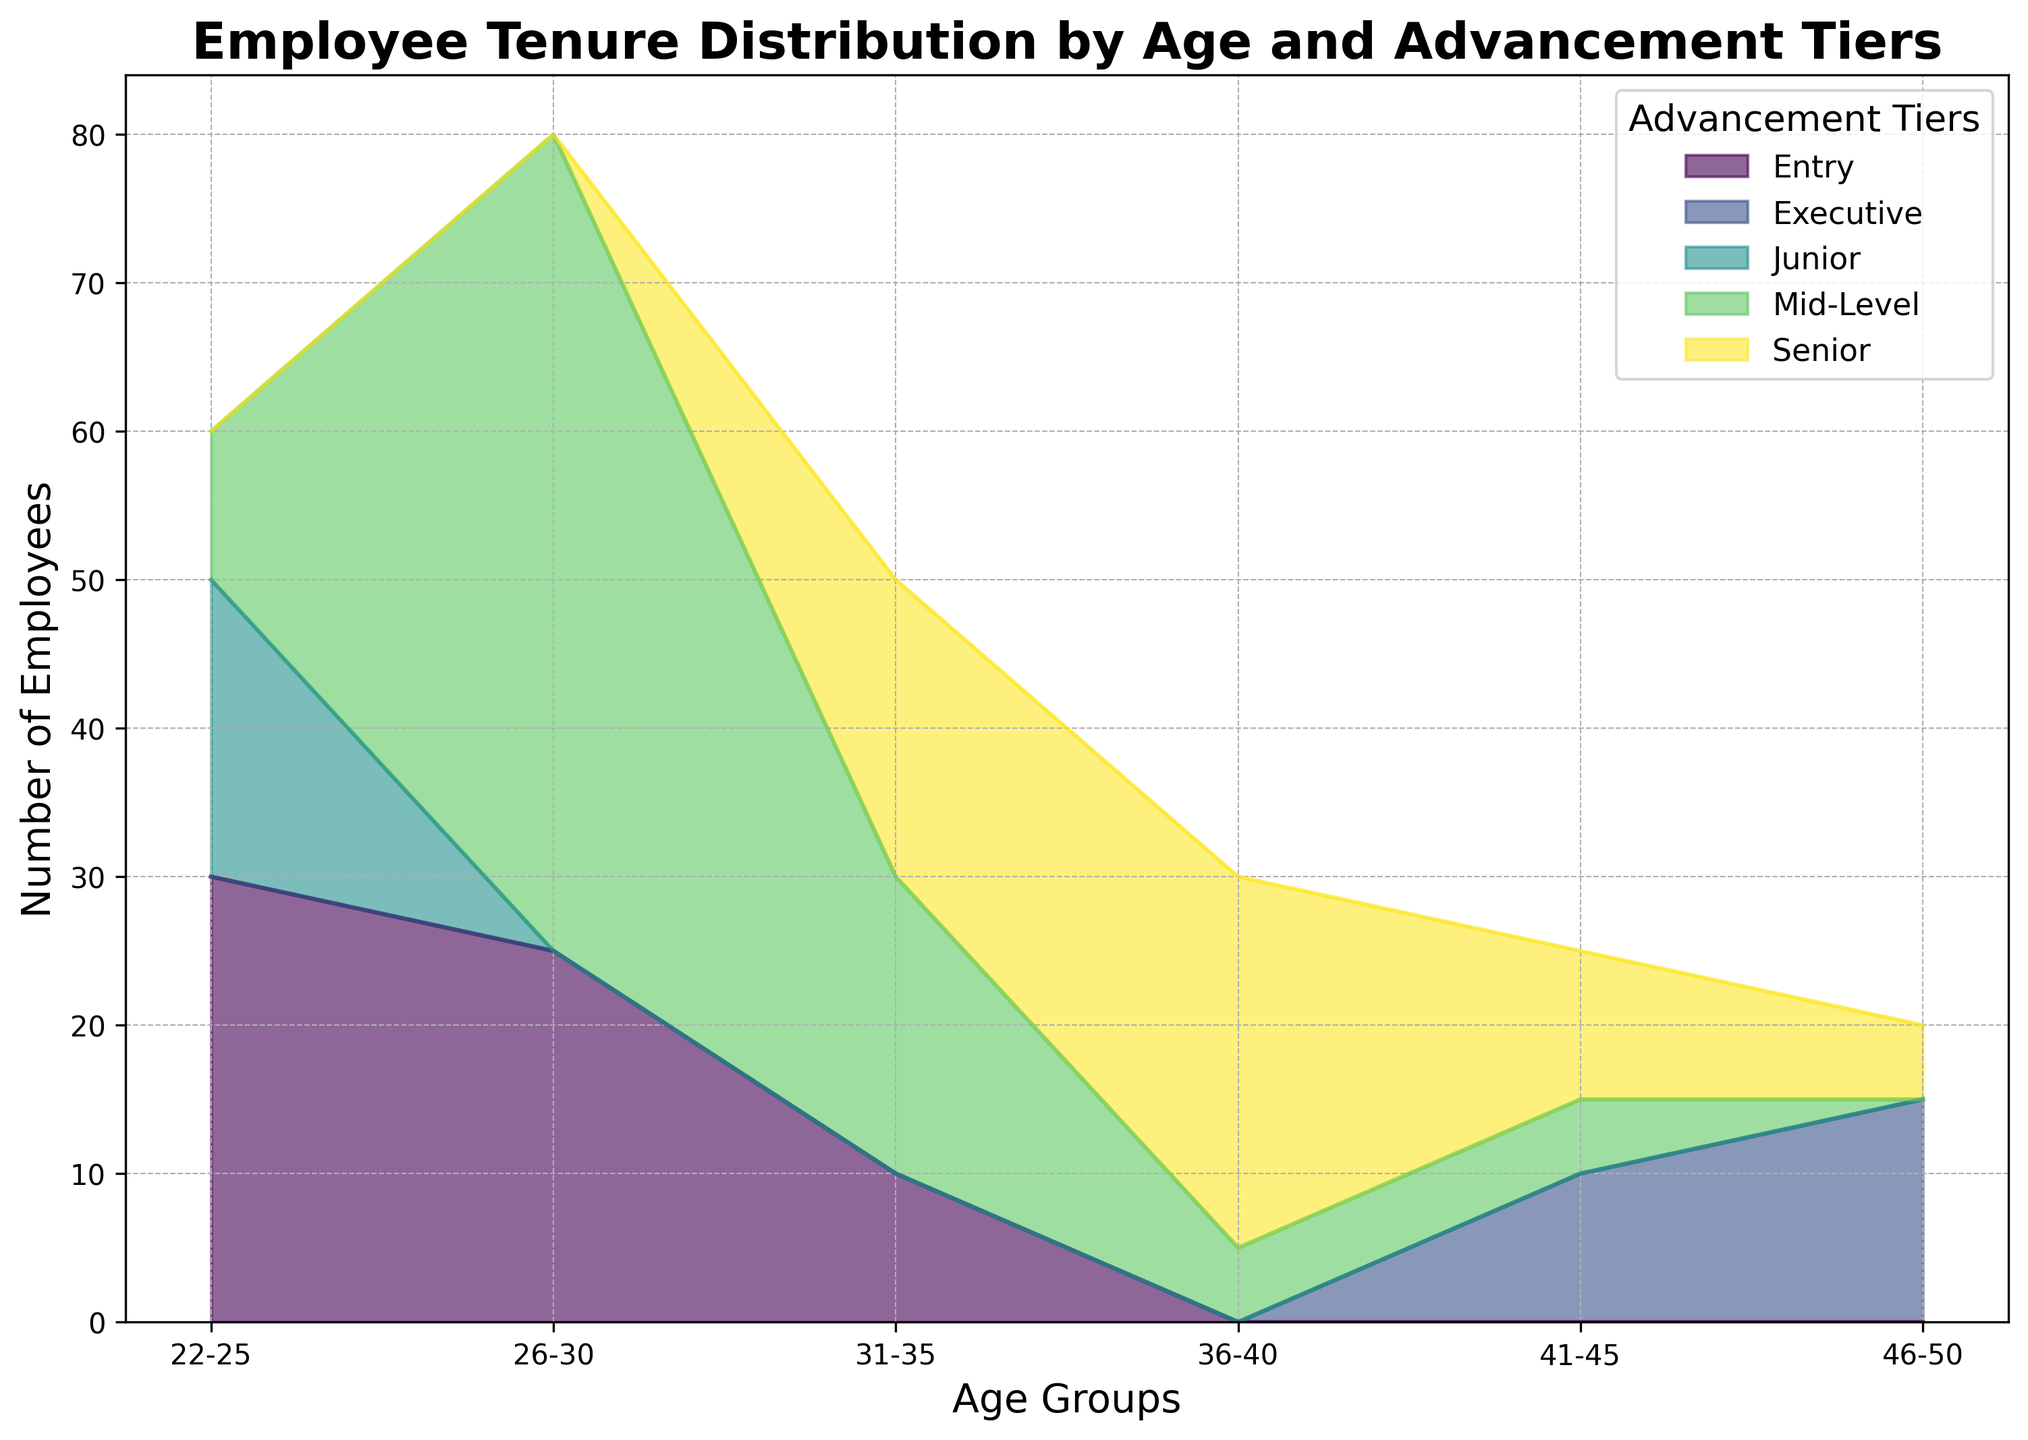What is the total number of employees in the 22-25 age group? To find the total number of employees in the 22-25 age group, sum the employee counts across all advancement tiers within that age group: 30 (Entry) + 20 (Junior) + 10 (Mid-Level) = 60
Answer: 60 Which advancement tier has the highest number of employees in the 31-35 age group? Look at the height of the area plots for the 31-35 age group. The tier with the largest visual area is Mid-Level, showing the highest employee count of 20.
Answer: Mid-Level How many employees in the 36-40 age group are in the Senior tier? Observe the visual segment corresponding to the Senior tier for the 36-40 age group. The count indicated is 15 employees.
Answer: 15 Which age group has the highest number of Entry level employees? Compare the visual height of the Entry tier areas across all age groups. The 22-25 age group has the highest visual area for Entry level with a count of 30 employees.
Answer: 22-25 Compare the total employees in the Senior tier across all age groups to the total employees in the Executive tier across all age groups. Which tier has more employees? Sum the employees for each age group in both the Senior and Executive tiers. Senior: 20 (31-35) + 10 (36-40) + 10 (41-45) + 5 (46-50) = 45. Executive: 10 (41-45) + 10 (46-50) + 5 (46-50) = 25. Therefore, the Senior tier has more employees.
Answer: Senior In the 26-30 age group, how many more employees are in the Mid-Level tier compared to the Entry tier? Identify the employee counts for the 26-30 age group: Mid-Level is 30+25=55, and Entry is 25. The difference is 55 - 25 = 30
Answer: 30 What's the total number of employees with 5-10 years of tenure across all age groups? Sum the counts for 5-10 years of tenure across all relevant age groups: 25 (26-30, Mid) + 20 (31-35, Mid) + 5 (36-40, Mid) = 50
Answer: 50 What color represents the Junior tier in the chart? Scan the legend to find the color associated with the Junior tier. It is shown in a specific color (e.g., green)
Answer: Green (assuming from seaborn variant color palette) Compare the number of employees in the 41-45 age group at the Senior level to those at the Executive level. Which is greater? Look at the data: Senior tier for 41-45 age group is 10, Executive tier is 10. They are equal.
Answer: Equal What advancement tier is sparsely populated in the 22-25 and 26-30 age groups? Observe the visual height for each tier within these age groups. The highest counts belong to Entry, Junior, and Mid-Level, but almost none extend beyond Mid-Level. Higher tiers like Senior and Executive are sparsely populated in these age groups.
Answer: Senior and Executive 